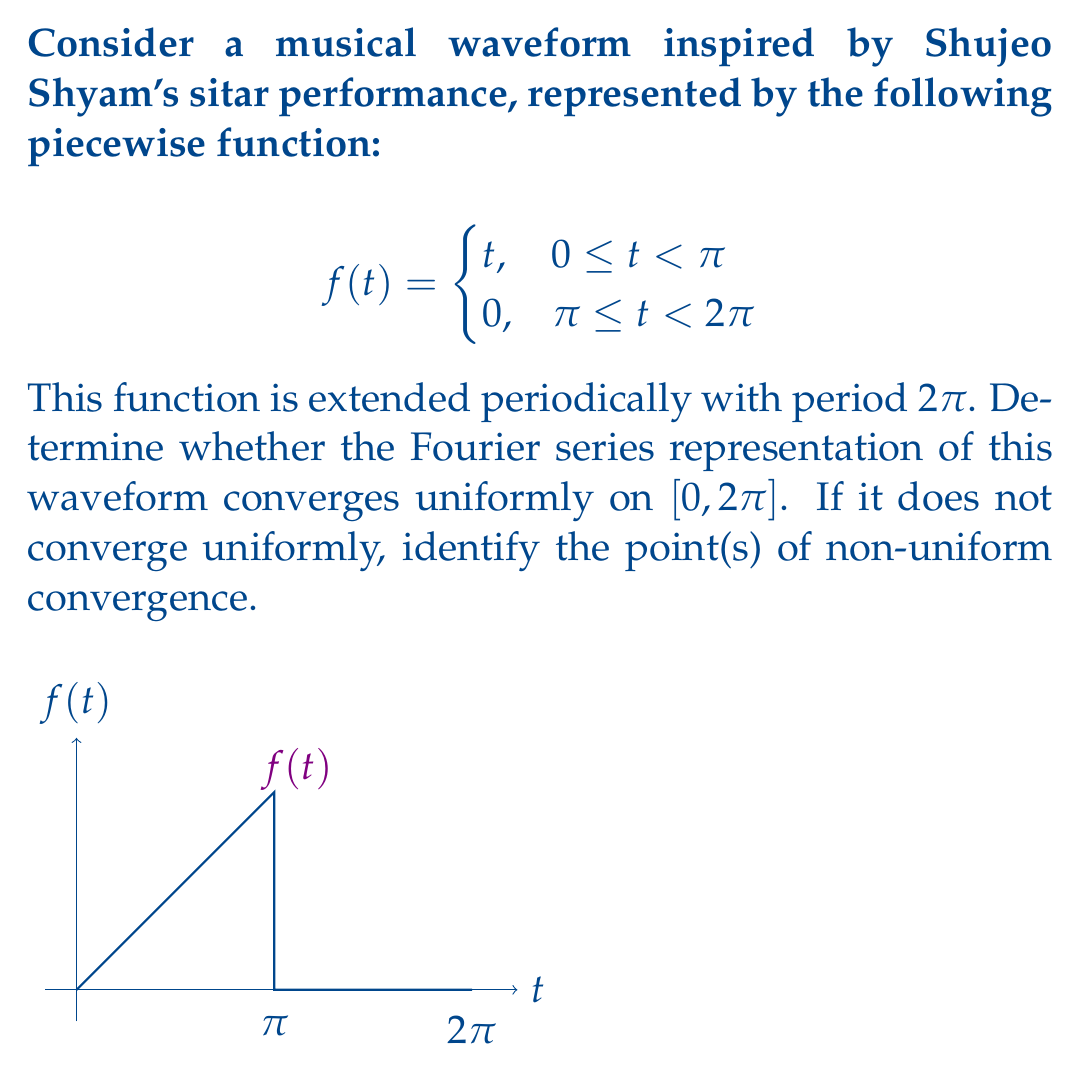Teach me how to tackle this problem. To analyze the convergence of the Fourier series representation, we'll follow these steps:

1) First, recall that for a function to have a uniformly convergent Fourier series on $[0, 2\pi]$, it must be continuous and have continuous periodic extensions.

2) Examine the continuity of $f(t)$:
   - $f(t)$ is continuous on $[0, \pi)$ and $(\pi, 2\pi]$
   - At $t = \pi$, there's a jump discontinuity:
     $\lim_{t \to \pi^-} f(t) = \pi$, while $\lim_{t \to \pi^+} f(t) = 0$

3) The periodic extension of $f(t)$ will also have jump discontinuities at odd multiples of $\pi$.

4) Due to these discontinuities, the Fourier series cannot converge uniformly on the entire interval $[0, 2\pi]$.

5) The Fourier series will exhibit the Gibbs phenomenon near the discontinuities, particularly at $t = \pi$.

6) However, the Fourier series will converge pointwise to $f(t)$ at all points where $f(t)$ is continuous, and to the average of the left and right limits at the discontinuities.

7) Points of non-uniform convergence:
   - $t = \pi$ (within $[0, 2\pi]$)
   - $t = 0$ and $t = 2\pi$ (considered the same point in the periodic extension)

8) At these points, the oscillations of the partial sums of the Fourier series will not diminish as the number of terms increases, leading to non-uniform convergence.
Answer: The Fourier series does not converge uniformly on $[0, 2\pi]$. Points of non-uniform convergence: $t = 0, \pi, 2\pi$. 